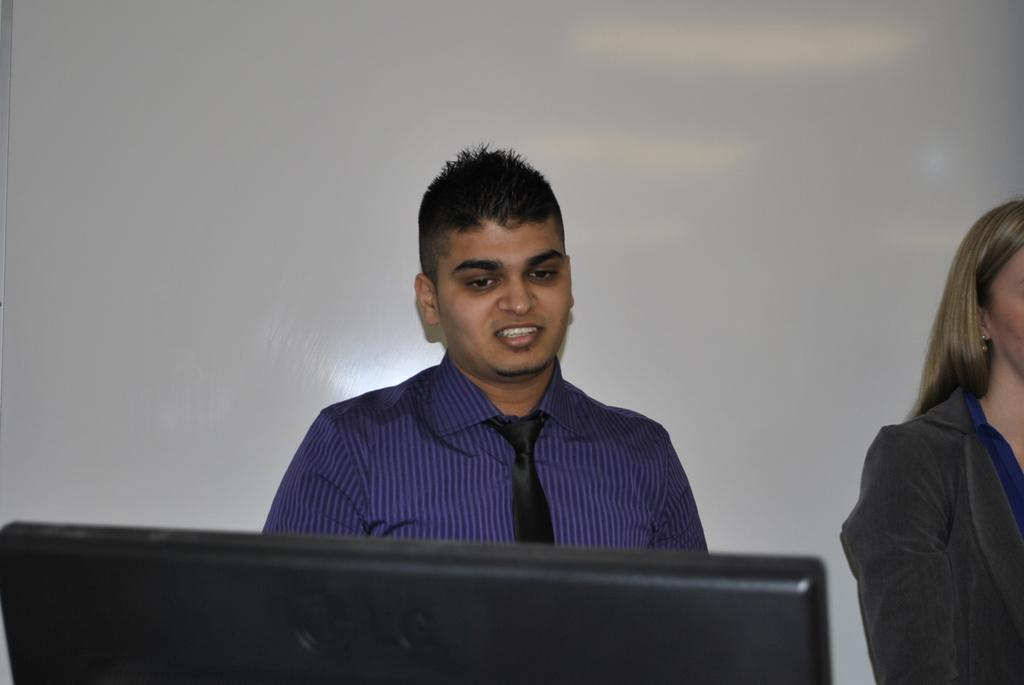How many individuals are present in the image? There are two people in the image. What are the people doing in the image? The people are on a path. What object is in front of one of the people? There is a black monitor in front of one of the people. What can be seen behind the people? There is a white wall behind the people. What type of volleyball game is being played in the image? There is no volleyball game present in the image. What experience can be gained from observing the people in the image? The image does not convey any specific experience that can be gained from observing the people. 